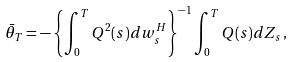Convert formula to latex. <formula><loc_0><loc_0><loc_500><loc_500>\bar { \theta } _ { T } = - \left \{ \int _ { 0 } ^ { T } Q ^ { 2 } ( s ) d w _ { s } ^ { H } \right \} ^ { - 1 } \int _ { 0 } ^ { T } Q ( s ) d Z _ { s } \, ,</formula> 